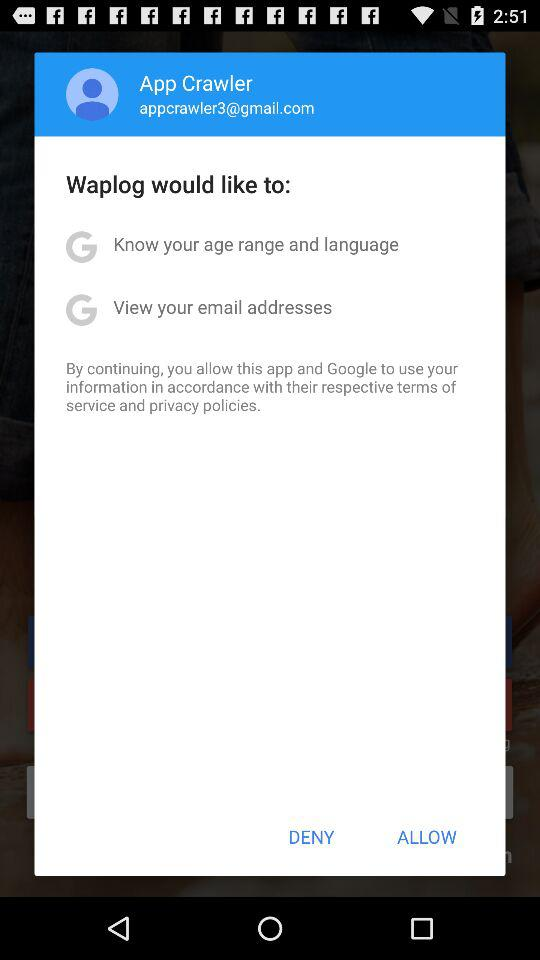What is the name of the user? The name of the user is App Crawler. 